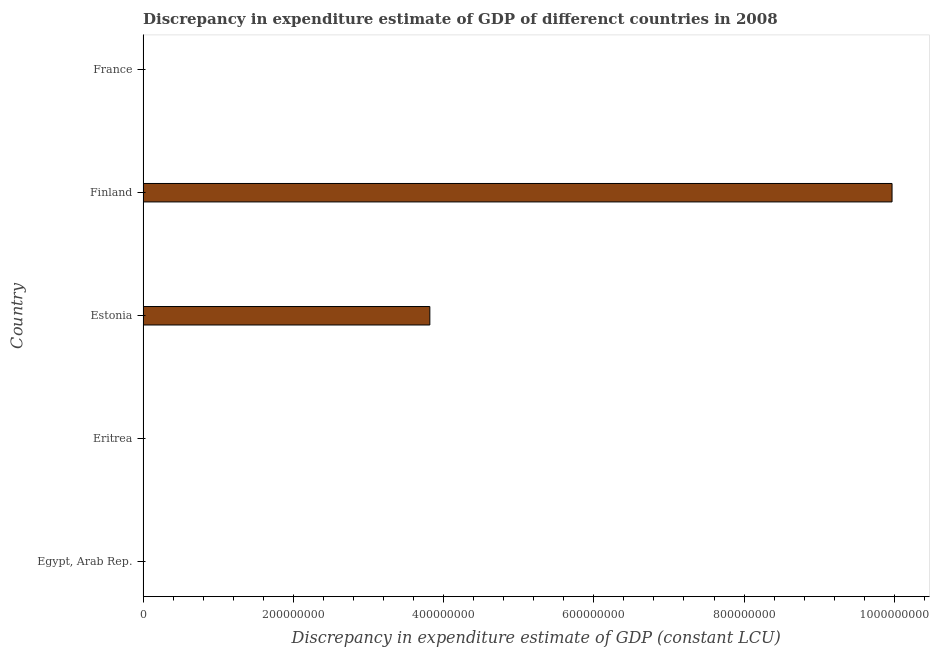Does the graph contain grids?
Provide a short and direct response. No. What is the title of the graph?
Provide a short and direct response. Discrepancy in expenditure estimate of GDP of differenct countries in 2008. What is the label or title of the X-axis?
Make the answer very short. Discrepancy in expenditure estimate of GDP (constant LCU). What is the label or title of the Y-axis?
Offer a terse response. Country. What is the discrepancy in expenditure estimate of gdp in Finland?
Ensure brevity in your answer.  9.97e+08. Across all countries, what is the maximum discrepancy in expenditure estimate of gdp?
Make the answer very short. 9.97e+08. What is the sum of the discrepancy in expenditure estimate of gdp?
Your response must be concise. 1.38e+09. What is the difference between the discrepancy in expenditure estimate of gdp in Eritrea and Finland?
Your answer should be compact. -9.97e+08. What is the average discrepancy in expenditure estimate of gdp per country?
Provide a short and direct response. 2.76e+08. What is the median discrepancy in expenditure estimate of gdp?
Offer a very short reply. 0. In how many countries, is the discrepancy in expenditure estimate of gdp greater than 960000000 LCU?
Provide a succinct answer. 1. What is the ratio of the discrepancy in expenditure estimate of gdp in Estonia to that in Finland?
Make the answer very short. 0.38. Is the difference between the discrepancy in expenditure estimate of gdp in Eritrea and Finland greater than the difference between any two countries?
Your answer should be very brief. No. What is the difference between the highest and the second highest discrepancy in expenditure estimate of gdp?
Your answer should be compact. 6.15e+08. What is the difference between the highest and the lowest discrepancy in expenditure estimate of gdp?
Give a very brief answer. 9.97e+08. How many bars are there?
Your response must be concise. 3. Are all the bars in the graph horizontal?
Make the answer very short. Yes. How many countries are there in the graph?
Ensure brevity in your answer.  5. What is the Discrepancy in expenditure estimate of GDP (constant LCU) of Egypt, Arab Rep.?
Provide a succinct answer. 0. What is the Discrepancy in expenditure estimate of GDP (constant LCU) in Eritrea?
Ensure brevity in your answer.  0. What is the Discrepancy in expenditure estimate of GDP (constant LCU) of Estonia?
Offer a very short reply. 3.82e+08. What is the Discrepancy in expenditure estimate of GDP (constant LCU) in Finland?
Offer a terse response. 9.97e+08. What is the difference between the Discrepancy in expenditure estimate of GDP (constant LCU) in Eritrea and Estonia?
Your answer should be very brief. -3.82e+08. What is the difference between the Discrepancy in expenditure estimate of GDP (constant LCU) in Eritrea and Finland?
Offer a very short reply. -9.97e+08. What is the difference between the Discrepancy in expenditure estimate of GDP (constant LCU) in Estonia and Finland?
Your answer should be compact. -6.15e+08. What is the ratio of the Discrepancy in expenditure estimate of GDP (constant LCU) in Estonia to that in Finland?
Keep it short and to the point. 0.38. 